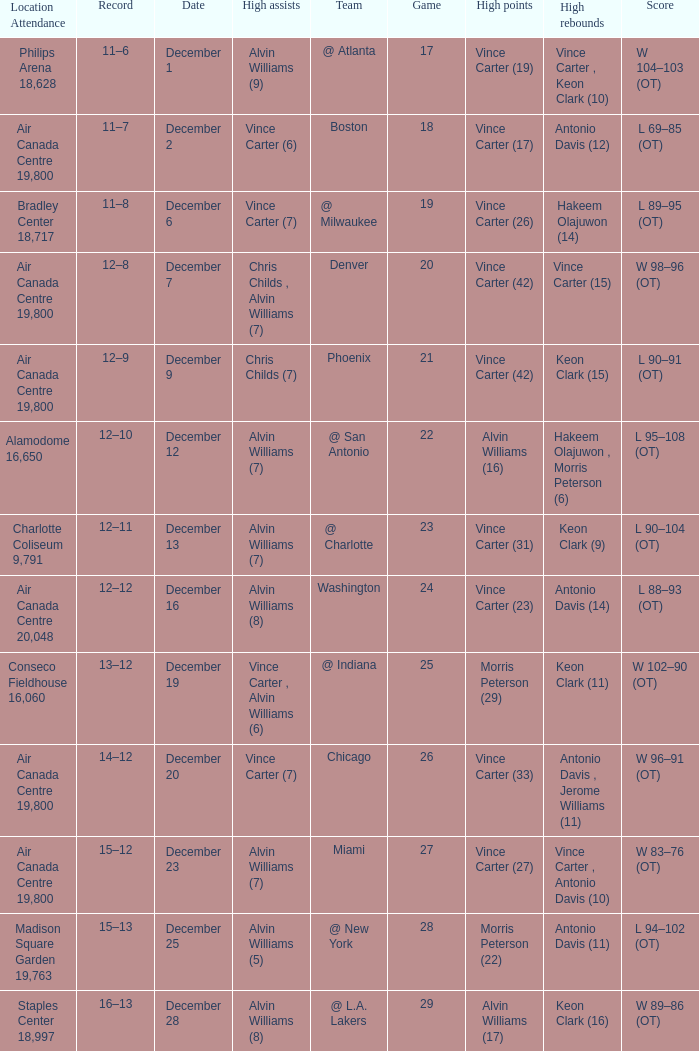Who scored the most points against Washington? Vince Carter (23). 